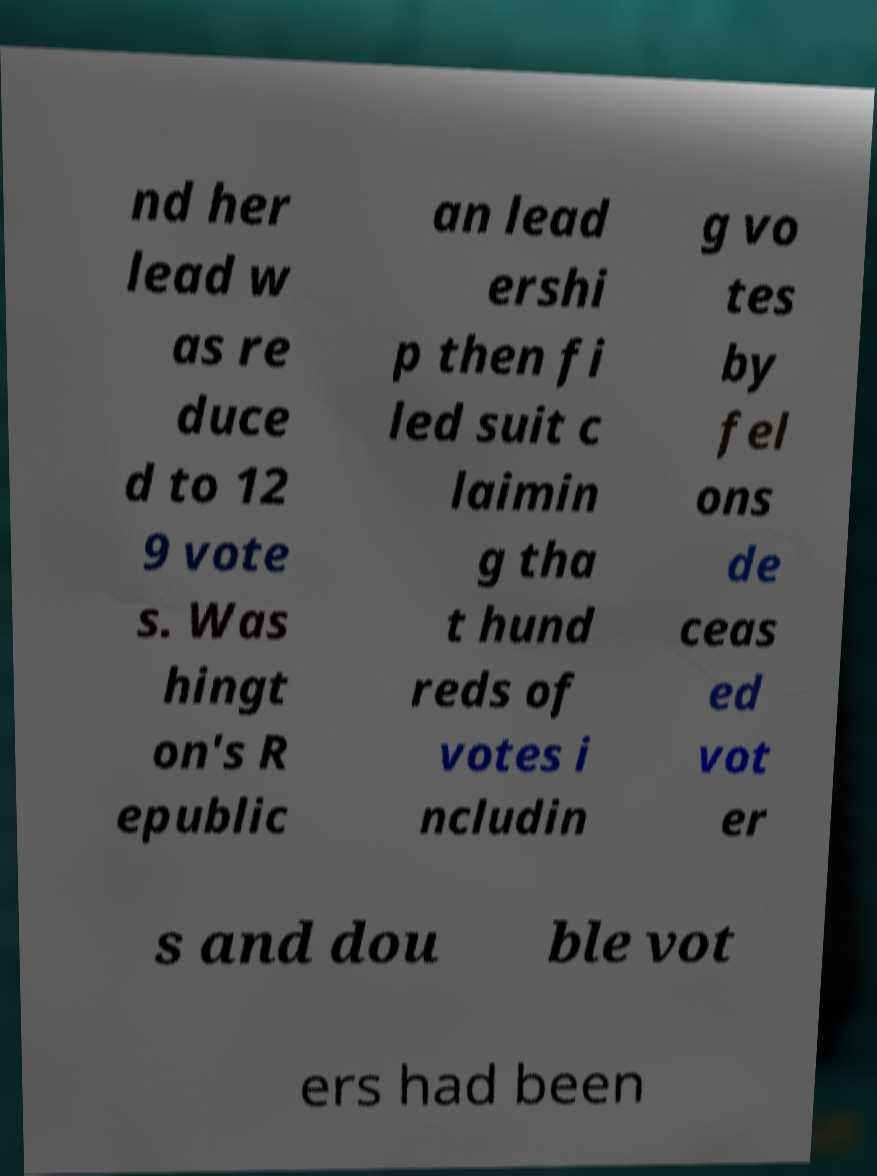Can you read and provide the text displayed in the image?This photo seems to have some interesting text. Can you extract and type it out for me? nd her lead w as re duce d to 12 9 vote s. Was hingt on's R epublic an lead ershi p then fi led suit c laimin g tha t hund reds of votes i ncludin g vo tes by fel ons de ceas ed vot er s and dou ble vot ers had been 